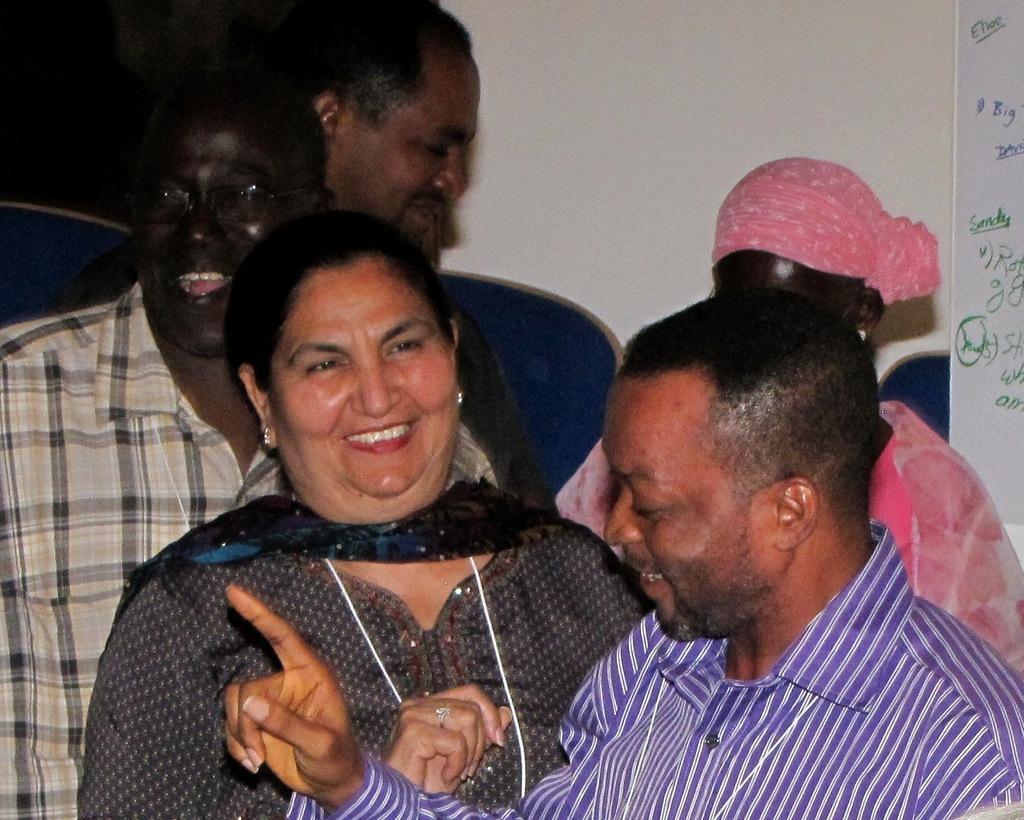Please provide a concise description of this image. In this image I can see a group of people standing in the center of the image. I can see a board on the right hand side of the image with some text. 